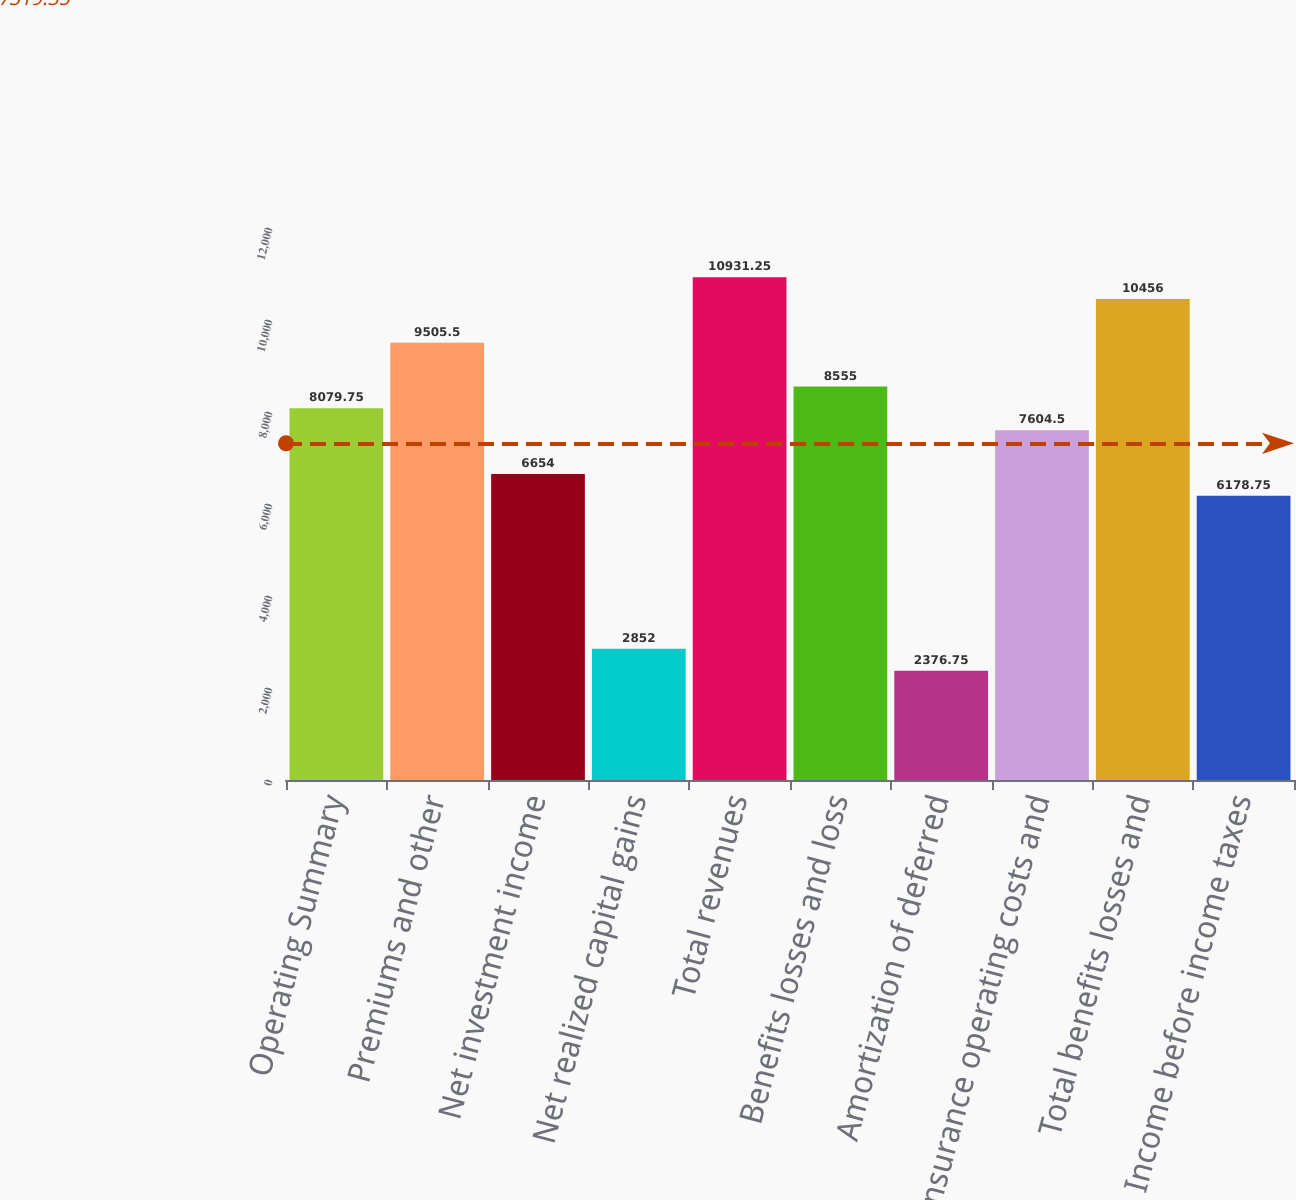<chart> <loc_0><loc_0><loc_500><loc_500><bar_chart><fcel>Operating Summary<fcel>Premiums and other<fcel>Net investment income<fcel>Net realized capital gains<fcel>Total revenues<fcel>Benefits losses and loss<fcel>Amortization of deferred<fcel>Insurance operating costs and<fcel>Total benefits losses and<fcel>Income before income taxes<nl><fcel>8079.75<fcel>9505.5<fcel>6654<fcel>2852<fcel>10931.2<fcel>8555<fcel>2376.75<fcel>7604.5<fcel>10456<fcel>6178.75<nl></chart> 